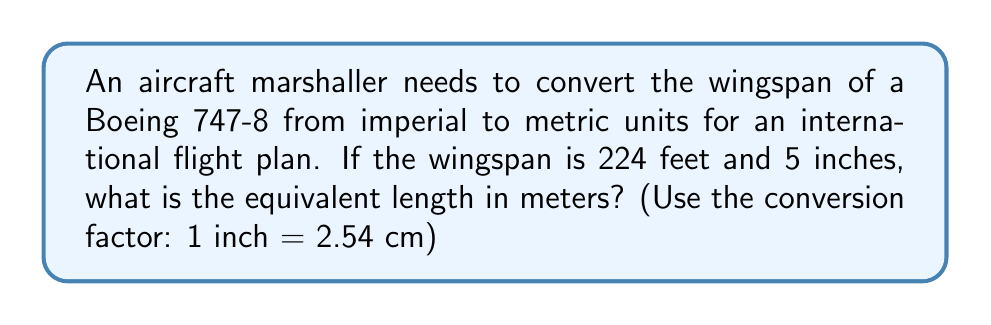Help me with this question. To solve this problem, we need to follow these steps:

1. Convert the wingspan to inches:
   $$(224 \text{ feet} \times 12 \text{ inches/foot}) + 5 \text{ inches} = 2693 \text{ inches}$$

2. Use the conversion factor to change inches to centimeters:
   $$2693 \text{ inches} \times 2.54 \text{ cm/inch} = 6840.22 \text{ cm}$$

3. Convert centimeters to meters:
   $$6840.22 \text{ cm} \div 100 \text{ cm/m} = 68.4022 \text{ m}$$

The final step is to round the answer to an appropriate number of decimal places. For aircraft specifications, two decimal places are usually sufficient.
Answer: The wingspan of the Boeing 747-8 is approximately 68.40 meters. 